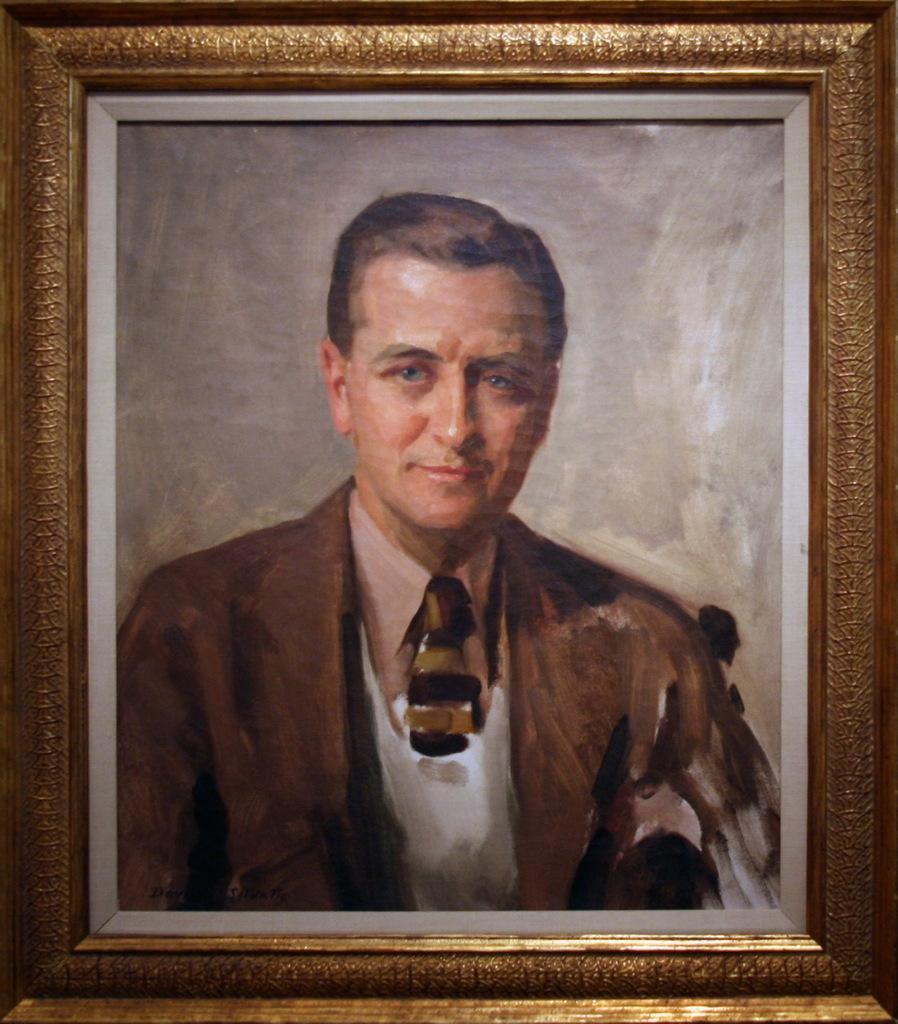Describe this image in one or two sentences. This looks like a photo frame. I can see the painting of the man smiling. This is the golden color frame. 